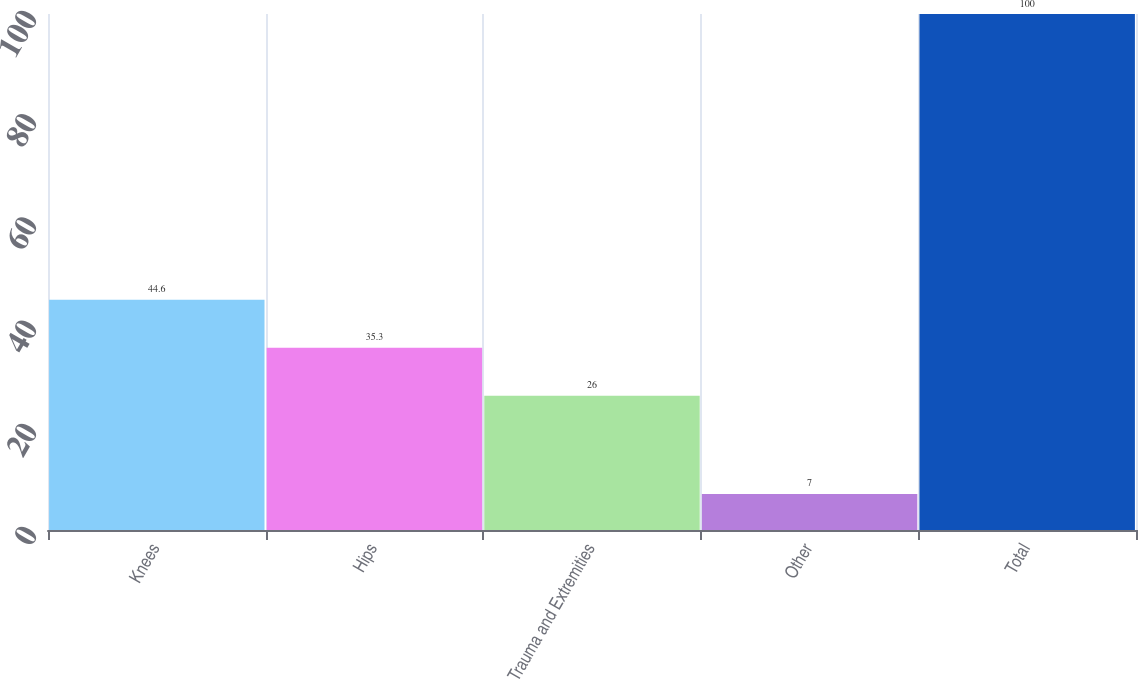Convert chart to OTSL. <chart><loc_0><loc_0><loc_500><loc_500><bar_chart><fcel>Knees<fcel>Hips<fcel>Trauma and Extremities<fcel>Other<fcel>Total<nl><fcel>44.6<fcel>35.3<fcel>26<fcel>7<fcel>100<nl></chart> 